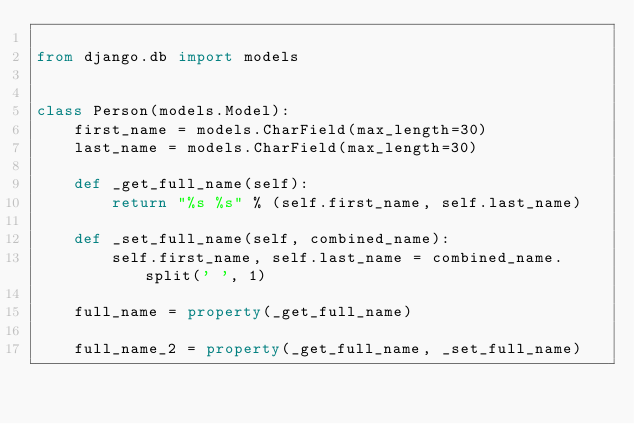<code> <loc_0><loc_0><loc_500><loc_500><_Python_>
from django.db import models


class Person(models.Model):
    first_name = models.CharField(max_length=30)
    last_name = models.CharField(max_length=30)

    def _get_full_name(self):
        return "%s %s" % (self.first_name, self.last_name)

    def _set_full_name(self, combined_name):
        self.first_name, self.last_name = combined_name.split(' ', 1)

    full_name = property(_get_full_name)

    full_name_2 = property(_get_full_name, _set_full_name)
</code> 